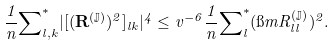<formula> <loc_0><loc_0><loc_500><loc_500>\frac { 1 } { n } { \sum } ^ { * } _ { l , k } | [ ( \mathbf R ^ { ( \mathbb { J } ) } ) ^ { 2 } ] _ { l k } | ^ { 4 } \leq v ^ { - 6 } \frac { 1 } { n } { \sum } ^ { * } _ { l } ( \i m R ^ { ( \mathbb { J } ) } _ { l l } ) ^ { 2 } .</formula> 